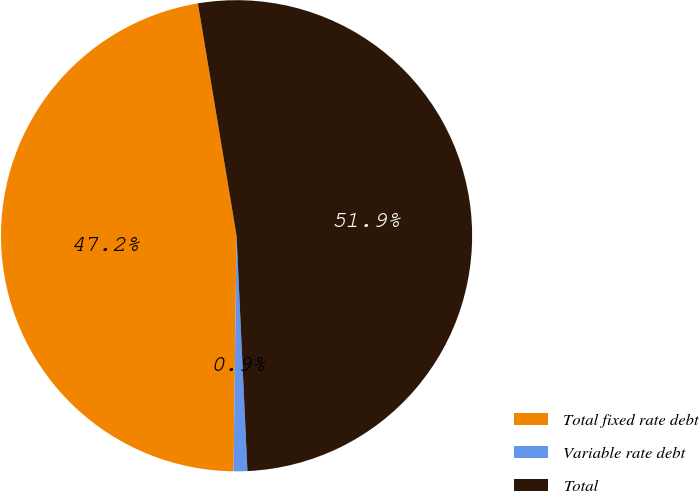Convert chart. <chart><loc_0><loc_0><loc_500><loc_500><pie_chart><fcel>Total fixed rate debt<fcel>Variable rate debt<fcel>Total<nl><fcel>47.17%<fcel>0.94%<fcel>51.89%<nl></chart> 